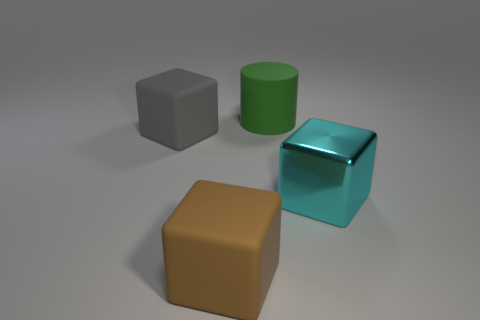Are there any other cyan things that have the same size as the cyan object?
Your answer should be compact. No. What material is the large cube on the right side of the large matte block that is on the right side of the big gray matte block that is behind the brown thing made of?
Offer a terse response. Metal. There is a large gray rubber object left of the big cyan shiny object; what number of large things are right of it?
Your response must be concise. 3. There is a thing right of the green object; is its size the same as the big brown block?
Give a very brief answer. Yes. What number of big brown matte objects are the same shape as the big cyan shiny object?
Offer a terse response. 1. What is the shape of the brown rubber object?
Give a very brief answer. Cube. Is the number of large blocks that are left of the rubber cylinder the same as the number of big matte blocks?
Keep it short and to the point. Yes. Is there anything else that is the same material as the large cyan object?
Offer a very short reply. No. Do the large block that is to the left of the brown matte block and the cyan object have the same material?
Give a very brief answer. No. Is the number of large gray matte blocks that are behind the large brown rubber cube less than the number of tiny blue matte cylinders?
Your response must be concise. No. 